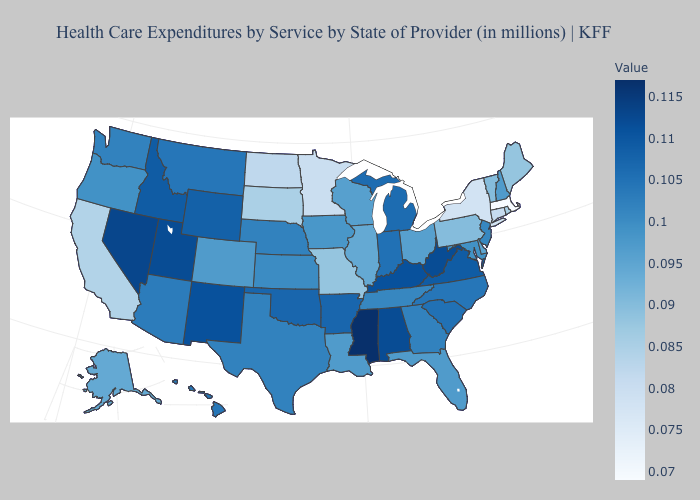Among the states that border North Carolina , does Georgia have the lowest value?
Be succinct. No. Which states have the highest value in the USA?
Write a very short answer. Mississippi. Does Connecticut have a lower value than Hawaii?
Concise answer only. Yes. 